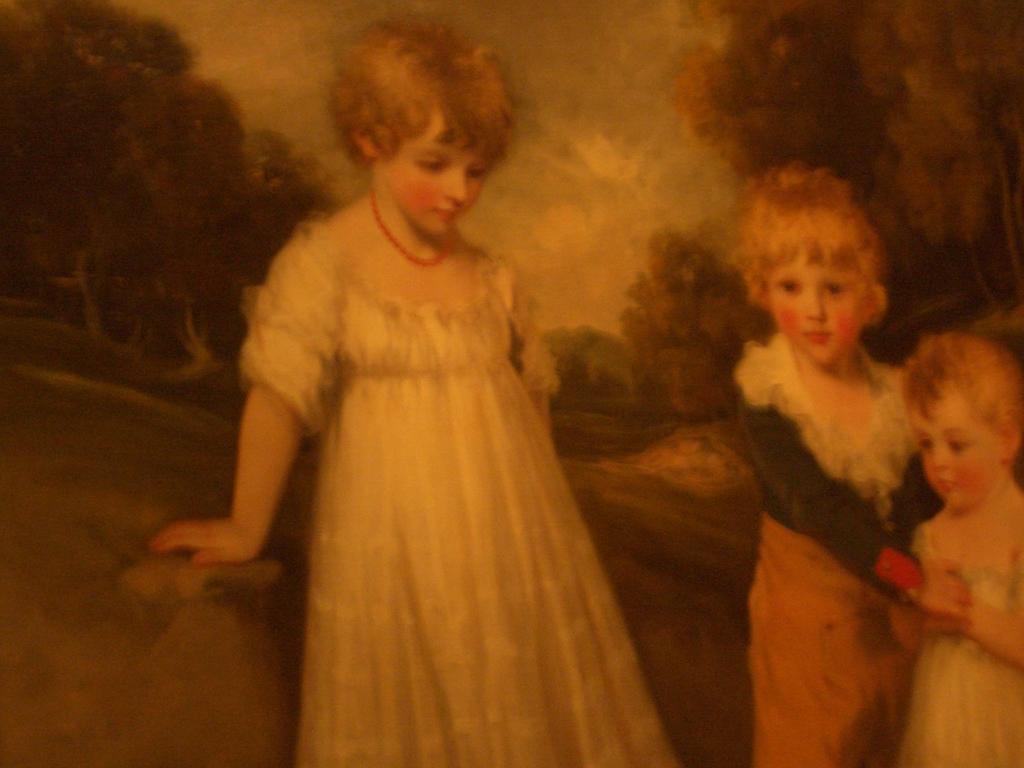Describe this image in one or two sentences. In the image we can see a painting. In the painting we can see there are three children wearing clothes and they are standing. Behind them there are many trees and a sky. 